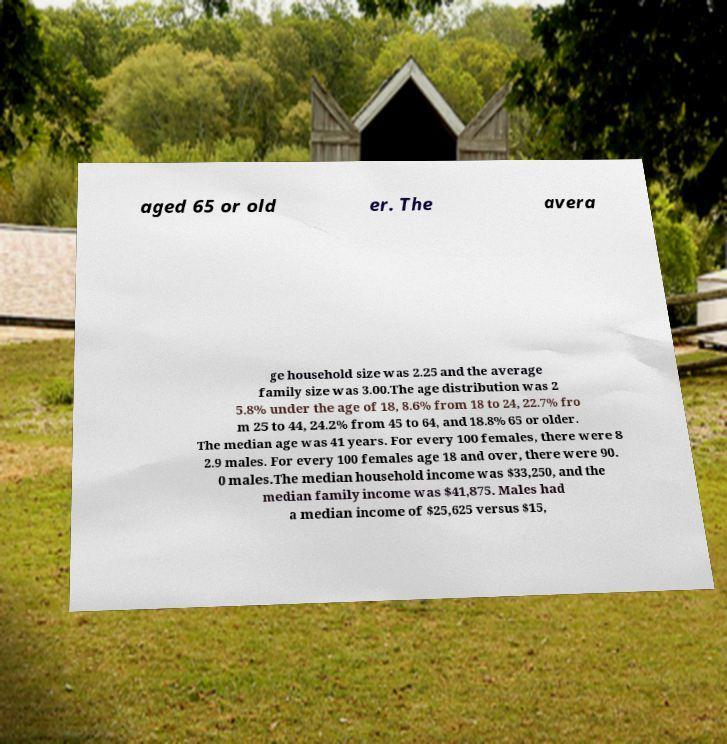For documentation purposes, I need the text within this image transcribed. Could you provide that? aged 65 or old er. The avera ge household size was 2.25 and the average family size was 3.00.The age distribution was 2 5.8% under the age of 18, 8.6% from 18 to 24, 22.7% fro m 25 to 44, 24.2% from 45 to 64, and 18.8% 65 or older. The median age was 41 years. For every 100 females, there were 8 2.9 males. For every 100 females age 18 and over, there were 90. 0 males.The median household income was $33,250, and the median family income was $41,875. Males had a median income of $25,625 versus $15, 